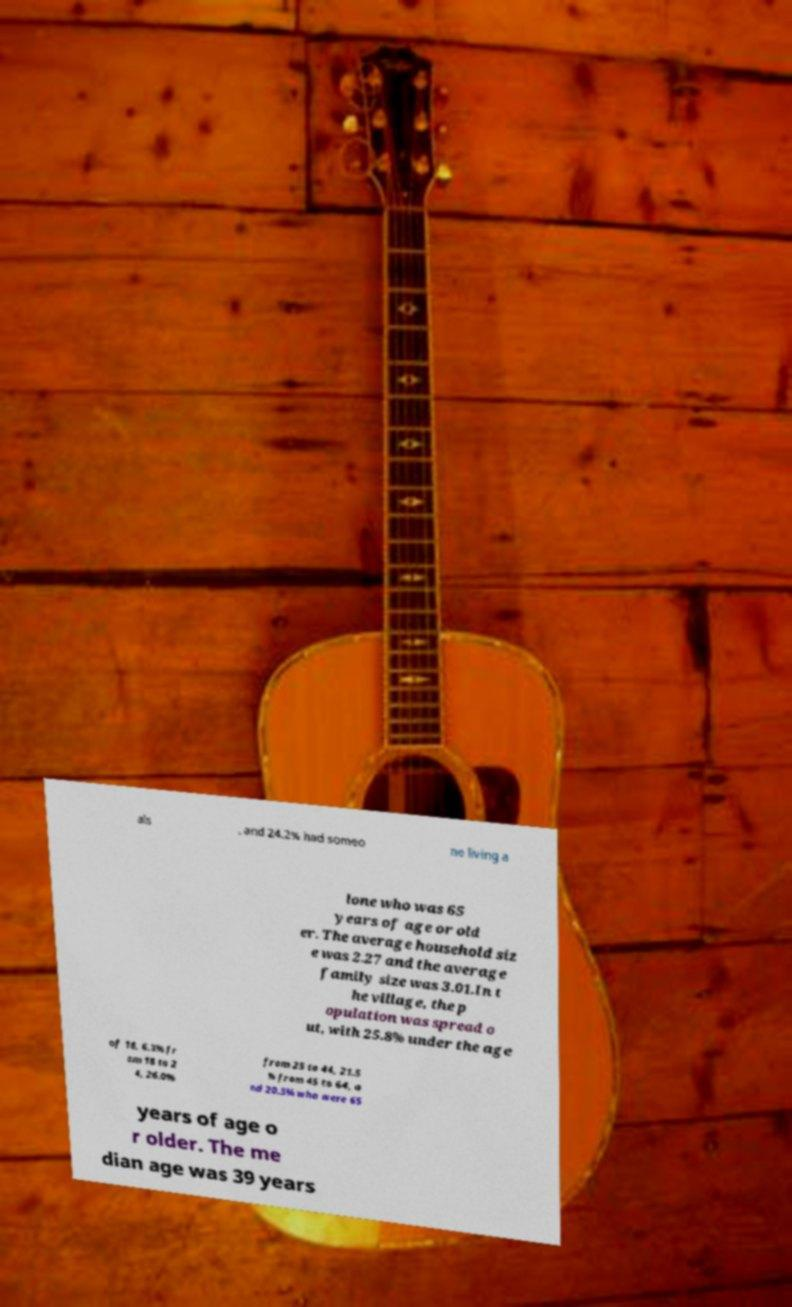Can you read and provide the text displayed in the image?This photo seems to have some interesting text. Can you extract and type it out for me? als , and 24.2% had someo ne living a lone who was 65 years of age or old er. The average household siz e was 2.27 and the average family size was 3.01.In t he village, the p opulation was spread o ut, with 25.8% under the age of 18, 6.3% fr om 18 to 2 4, 26.0% from 25 to 44, 21.5 % from 45 to 64, a nd 20.3% who were 65 years of age o r older. The me dian age was 39 years 